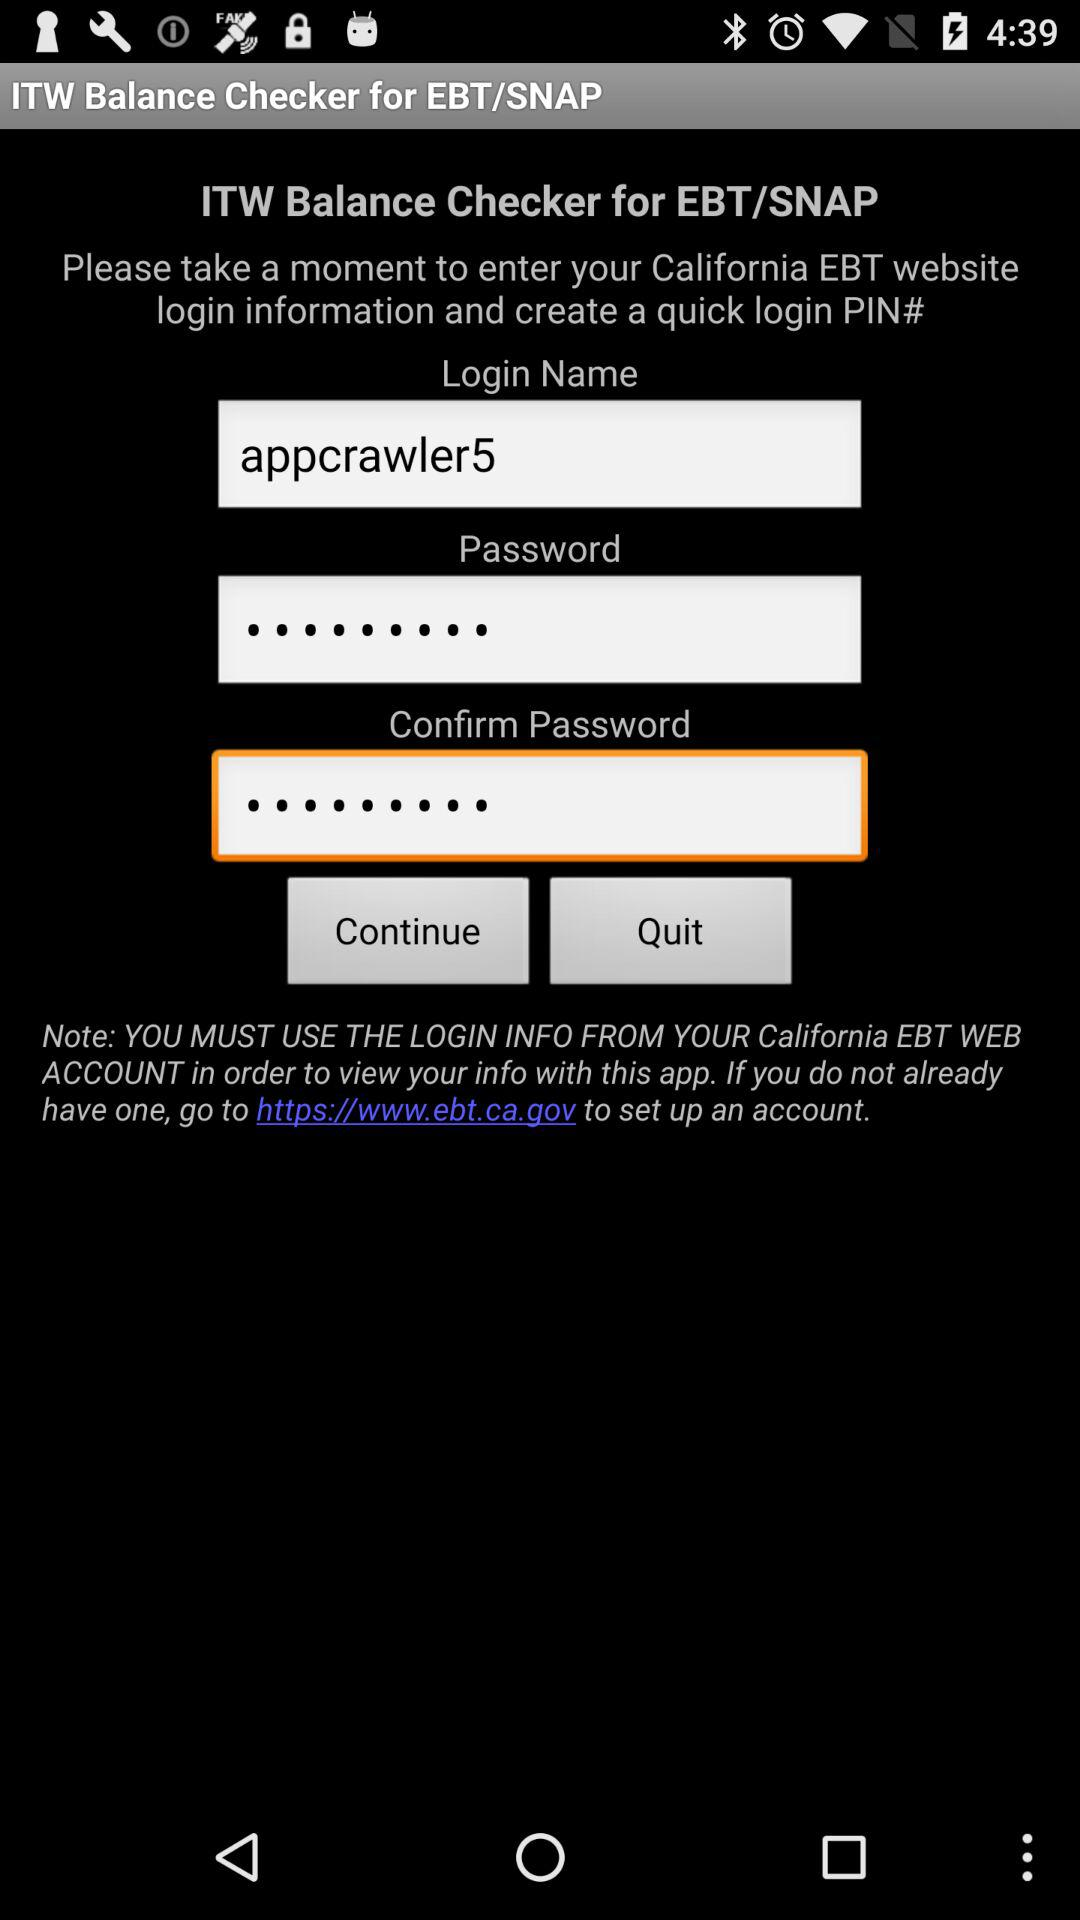What is the app name? The app name is "ITW Balance Checker for EBT/SNAP". 